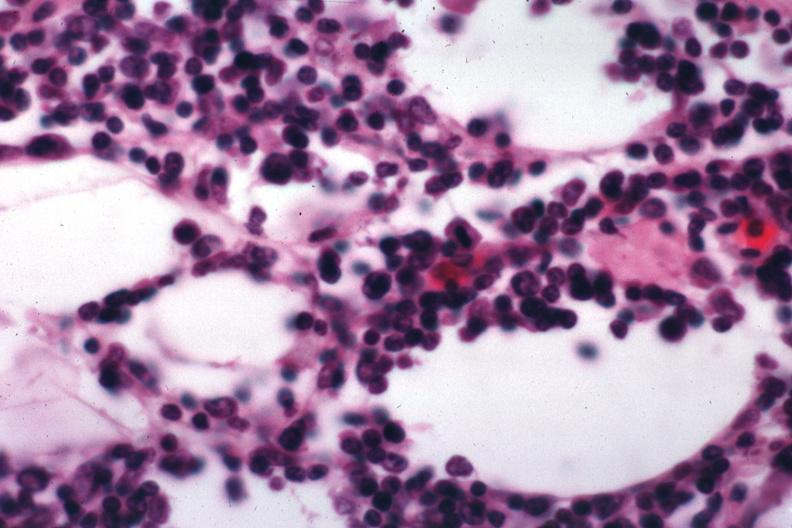what is present?
Answer the question using a single word or phrase. Malignant lymphoma 